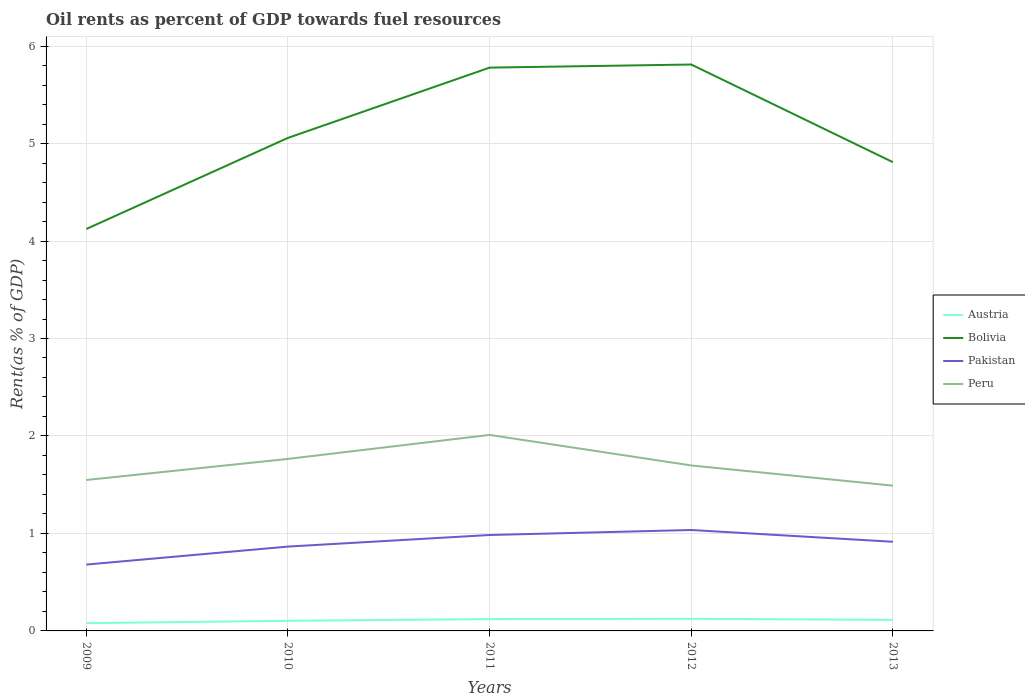Across all years, what is the maximum oil rent in Austria?
Provide a short and direct response. 0.08. In which year was the oil rent in Pakistan maximum?
Ensure brevity in your answer.  2009. What is the total oil rent in Bolivia in the graph?
Your response must be concise. -0.93. What is the difference between the highest and the second highest oil rent in Bolivia?
Provide a short and direct response. 1.69. What is the difference between the highest and the lowest oil rent in Peru?
Provide a succinct answer. 2. How many years are there in the graph?
Your answer should be compact. 5. What is the difference between two consecutive major ticks on the Y-axis?
Offer a terse response. 1. Are the values on the major ticks of Y-axis written in scientific E-notation?
Offer a terse response. No. Does the graph contain any zero values?
Keep it short and to the point. No. Does the graph contain grids?
Provide a succinct answer. Yes. Where does the legend appear in the graph?
Your response must be concise. Center right. How many legend labels are there?
Keep it short and to the point. 4. How are the legend labels stacked?
Make the answer very short. Vertical. What is the title of the graph?
Offer a very short reply. Oil rents as percent of GDP towards fuel resources. What is the label or title of the Y-axis?
Make the answer very short. Rent(as % of GDP). What is the Rent(as % of GDP) in Austria in 2009?
Offer a terse response. 0.08. What is the Rent(as % of GDP) in Bolivia in 2009?
Ensure brevity in your answer.  4.12. What is the Rent(as % of GDP) in Pakistan in 2009?
Offer a terse response. 0.68. What is the Rent(as % of GDP) in Peru in 2009?
Give a very brief answer. 1.55. What is the Rent(as % of GDP) of Austria in 2010?
Provide a succinct answer. 0.1. What is the Rent(as % of GDP) in Bolivia in 2010?
Keep it short and to the point. 5.06. What is the Rent(as % of GDP) of Pakistan in 2010?
Give a very brief answer. 0.87. What is the Rent(as % of GDP) of Peru in 2010?
Offer a terse response. 1.76. What is the Rent(as % of GDP) of Austria in 2011?
Provide a succinct answer. 0.12. What is the Rent(as % of GDP) of Bolivia in 2011?
Provide a succinct answer. 5.78. What is the Rent(as % of GDP) of Pakistan in 2011?
Provide a short and direct response. 0.98. What is the Rent(as % of GDP) of Peru in 2011?
Your answer should be very brief. 2.01. What is the Rent(as % of GDP) of Austria in 2012?
Your answer should be compact. 0.12. What is the Rent(as % of GDP) in Bolivia in 2012?
Offer a terse response. 5.81. What is the Rent(as % of GDP) of Pakistan in 2012?
Keep it short and to the point. 1.04. What is the Rent(as % of GDP) of Peru in 2012?
Ensure brevity in your answer.  1.7. What is the Rent(as % of GDP) in Austria in 2013?
Offer a very short reply. 0.11. What is the Rent(as % of GDP) of Bolivia in 2013?
Your response must be concise. 4.81. What is the Rent(as % of GDP) of Pakistan in 2013?
Keep it short and to the point. 0.91. What is the Rent(as % of GDP) in Peru in 2013?
Offer a terse response. 1.49. Across all years, what is the maximum Rent(as % of GDP) of Austria?
Give a very brief answer. 0.12. Across all years, what is the maximum Rent(as % of GDP) of Bolivia?
Offer a very short reply. 5.81. Across all years, what is the maximum Rent(as % of GDP) of Pakistan?
Keep it short and to the point. 1.04. Across all years, what is the maximum Rent(as % of GDP) of Peru?
Provide a short and direct response. 2.01. Across all years, what is the minimum Rent(as % of GDP) in Austria?
Your response must be concise. 0.08. Across all years, what is the minimum Rent(as % of GDP) in Bolivia?
Your answer should be compact. 4.12. Across all years, what is the minimum Rent(as % of GDP) in Pakistan?
Offer a terse response. 0.68. Across all years, what is the minimum Rent(as % of GDP) in Peru?
Make the answer very short. 1.49. What is the total Rent(as % of GDP) in Austria in the graph?
Offer a very short reply. 0.54. What is the total Rent(as % of GDP) of Bolivia in the graph?
Make the answer very short. 25.58. What is the total Rent(as % of GDP) in Pakistan in the graph?
Make the answer very short. 4.48. What is the total Rent(as % of GDP) of Peru in the graph?
Provide a short and direct response. 8.51. What is the difference between the Rent(as % of GDP) in Austria in 2009 and that in 2010?
Your answer should be very brief. -0.02. What is the difference between the Rent(as % of GDP) in Bolivia in 2009 and that in 2010?
Make the answer very short. -0.93. What is the difference between the Rent(as % of GDP) in Pakistan in 2009 and that in 2010?
Keep it short and to the point. -0.18. What is the difference between the Rent(as % of GDP) in Peru in 2009 and that in 2010?
Offer a terse response. -0.22. What is the difference between the Rent(as % of GDP) of Austria in 2009 and that in 2011?
Keep it short and to the point. -0.04. What is the difference between the Rent(as % of GDP) in Bolivia in 2009 and that in 2011?
Provide a succinct answer. -1.66. What is the difference between the Rent(as % of GDP) in Pakistan in 2009 and that in 2011?
Keep it short and to the point. -0.3. What is the difference between the Rent(as % of GDP) of Peru in 2009 and that in 2011?
Offer a very short reply. -0.46. What is the difference between the Rent(as % of GDP) of Austria in 2009 and that in 2012?
Give a very brief answer. -0.04. What is the difference between the Rent(as % of GDP) of Bolivia in 2009 and that in 2012?
Offer a very short reply. -1.69. What is the difference between the Rent(as % of GDP) in Pakistan in 2009 and that in 2012?
Ensure brevity in your answer.  -0.35. What is the difference between the Rent(as % of GDP) of Peru in 2009 and that in 2012?
Your answer should be very brief. -0.15. What is the difference between the Rent(as % of GDP) in Austria in 2009 and that in 2013?
Your response must be concise. -0.03. What is the difference between the Rent(as % of GDP) in Bolivia in 2009 and that in 2013?
Your answer should be very brief. -0.69. What is the difference between the Rent(as % of GDP) in Pakistan in 2009 and that in 2013?
Your response must be concise. -0.23. What is the difference between the Rent(as % of GDP) in Peru in 2009 and that in 2013?
Your answer should be compact. 0.06. What is the difference between the Rent(as % of GDP) of Austria in 2010 and that in 2011?
Your answer should be compact. -0.02. What is the difference between the Rent(as % of GDP) of Bolivia in 2010 and that in 2011?
Keep it short and to the point. -0.72. What is the difference between the Rent(as % of GDP) in Pakistan in 2010 and that in 2011?
Give a very brief answer. -0.12. What is the difference between the Rent(as % of GDP) of Peru in 2010 and that in 2011?
Make the answer very short. -0.25. What is the difference between the Rent(as % of GDP) in Austria in 2010 and that in 2012?
Keep it short and to the point. -0.02. What is the difference between the Rent(as % of GDP) in Bolivia in 2010 and that in 2012?
Provide a short and direct response. -0.75. What is the difference between the Rent(as % of GDP) of Pakistan in 2010 and that in 2012?
Your response must be concise. -0.17. What is the difference between the Rent(as % of GDP) of Peru in 2010 and that in 2012?
Provide a succinct answer. 0.07. What is the difference between the Rent(as % of GDP) of Austria in 2010 and that in 2013?
Provide a succinct answer. -0.01. What is the difference between the Rent(as % of GDP) in Bolivia in 2010 and that in 2013?
Offer a very short reply. 0.25. What is the difference between the Rent(as % of GDP) in Pakistan in 2010 and that in 2013?
Your answer should be very brief. -0.05. What is the difference between the Rent(as % of GDP) in Peru in 2010 and that in 2013?
Make the answer very short. 0.27. What is the difference between the Rent(as % of GDP) of Austria in 2011 and that in 2012?
Make the answer very short. -0. What is the difference between the Rent(as % of GDP) of Bolivia in 2011 and that in 2012?
Keep it short and to the point. -0.03. What is the difference between the Rent(as % of GDP) of Pakistan in 2011 and that in 2012?
Ensure brevity in your answer.  -0.05. What is the difference between the Rent(as % of GDP) of Peru in 2011 and that in 2012?
Keep it short and to the point. 0.31. What is the difference between the Rent(as % of GDP) in Austria in 2011 and that in 2013?
Offer a terse response. 0.01. What is the difference between the Rent(as % of GDP) of Bolivia in 2011 and that in 2013?
Offer a terse response. 0.97. What is the difference between the Rent(as % of GDP) in Pakistan in 2011 and that in 2013?
Your answer should be very brief. 0.07. What is the difference between the Rent(as % of GDP) of Peru in 2011 and that in 2013?
Keep it short and to the point. 0.52. What is the difference between the Rent(as % of GDP) in Austria in 2012 and that in 2013?
Ensure brevity in your answer.  0.01. What is the difference between the Rent(as % of GDP) of Pakistan in 2012 and that in 2013?
Your response must be concise. 0.12. What is the difference between the Rent(as % of GDP) of Peru in 2012 and that in 2013?
Provide a succinct answer. 0.21. What is the difference between the Rent(as % of GDP) in Austria in 2009 and the Rent(as % of GDP) in Bolivia in 2010?
Your answer should be compact. -4.98. What is the difference between the Rent(as % of GDP) in Austria in 2009 and the Rent(as % of GDP) in Pakistan in 2010?
Your response must be concise. -0.79. What is the difference between the Rent(as % of GDP) of Austria in 2009 and the Rent(as % of GDP) of Peru in 2010?
Provide a short and direct response. -1.69. What is the difference between the Rent(as % of GDP) in Bolivia in 2009 and the Rent(as % of GDP) in Pakistan in 2010?
Offer a very short reply. 3.26. What is the difference between the Rent(as % of GDP) of Bolivia in 2009 and the Rent(as % of GDP) of Peru in 2010?
Your response must be concise. 2.36. What is the difference between the Rent(as % of GDP) of Pakistan in 2009 and the Rent(as % of GDP) of Peru in 2010?
Offer a terse response. -1.08. What is the difference between the Rent(as % of GDP) of Austria in 2009 and the Rent(as % of GDP) of Bolivia in 2011?
Make the answer very short. -5.7. What is the difference between the Rent(as % of GDP) in Austria in 2009 and the Rent(as % of GDP) in Pakistan in 2011?
Provide a succinct answer. -0.9. What is the difference between the Rent(as % of GDP) in Austria in 2009 and the Rent(as % of GDP) in Peru in 2011?
Give a very brief answer. -1.93. What is the difference between the Rent(as % of GDP) in Bolivia in 2009 and the Rent(as % of GDP) in Pakistan in 2011?
Give a very brief answer. 3.14. What is the difference between the Rent(as % of GDP) of Bolivia in 2009 and the Rent(as % of GDP) of Peru in 2011?
Make the answer very short. 2.11. What is the difference between the Rent(as % of GDP) of Pakistan in 2009 and the Rent(as % of GDP) of Peru in 2011?
Provide a short and direct response. -1.33. What is the difference between the Rent(as % of GDP) in Austria in 2009 and the Rent(as % of GDP) in Bolivia in 2012?
Make the answer very short. -5.73. What is the difference between the Rent(as % of GDP) of Austria in 2009 and the Rent(as % of GDP) of Pakistan in 2012?
Offer a terse response. -0.96. What is the difference between the Rent(as % of GDP) in Austria in 2009 and the Rent(as % of GDP) in Peru in 2012?
Your response must be concise. -1.62. What is the difference between the Rent(as % of GDP) in Bolivia in 2009 and the Rent(as % of GDP) in Pakistan in 2012?
Offer a terse response. 3.09. What is the difference between the Rent(as % of GDP) of Bolivia in 2009 and the Rent(as % of GDP) of Peru in 2012?
Ensure brevity in your answer.  2.43. What is the difference between the Rent(as % of GDP) in Pakistan in 2009 and the Rent(as % of GDP) in Peru in 2012?
Offer a terse response. -1.02. What is the difference between the Rent(as % of GDP) in Austria in 2009 and the Rent(as % of GDP) in Bolivia in 2013?
Your response must be concise. -4.73. What is the difference between the Rent(as % of GDP) in Austria in 2009 and the Rent(as % of GDP) in Pakistan in 2013?
Your response must be concise. -0.84. What is the difference between the Rent(as % of GDP) of Austria in 2009 and the Rent(as % of GDP) of Peru in 2013?
Offer a very short reply. -1.41. What is the difference between the Rent(as % of GDP) in Bolivia in 2009 and the Rent(as % of GDP) in Pakistan in 2013?
Your response must be concise. 3.21. What is the difference between the Rent(as % of GDP) of Bolivia in 2009 and the Rent(as % of GDP) of Peru in 2013?
Make the answer very short. 2.63. What is the difference between the Rent(as % of GDP) in Pakistan in 2009 and the Rent(as % of GDP) in Peru in 2013?
Provide a succinct answer. -0.81. What is the difference between the Rent(as % of GDP) in Austria in 2010 and the Rent(as % of GDP) in Bolivia in 2011?
Keep it short and to the point. -5.67. What is the difference between the Rent(as % of GDP) in Austria in 2010 and the Rent(as % of GDP) in Pakistan in 2011?
Offer a terse response. -0.88. What is the difference between the Rent(as % of GDP) of Austria in 2010 and the Rent(as % of GDP) of Peru in 2011?
Your answer should be compact. -1.91. What is the difference between the Rent(as % of GDP) in Bolivia in 2010 and the Rent(as % of GDP) in Pakistan in 2011?
Ensure brevity in your answer.  4.07. What is the difference between the Rent(as % of GDP) in Bolivia in 2010 and the Rent(as % of GDP) in Peru in 2011?
Provide a succinct answer. 3.05. What is the difference between the Rent(as % of GDP) of Pakistan in 2010 and the Rent(as % of GDP) of Peru in 2011?
Provide a succinct answer. -1.15. What is the difference between the Rent(as % of GDP) in Austria in 2010 and the Rent(as % of GDP) in Bolivia in 2012?
Offer a terse response. -5.71. What is the difference between the Rent(as % of GDP) of Austria in 2010 and the Rent(as % of GDP) of Pakistan in 2012?
Keep it short and to the point. -0.93. What is the difference between the Rent(as % of GDP) of Austria in 2010 and the Rent(as % of GDP) of Peru in 2012?
Provide a short and direct response. -1.59. What is the difference between the Rent(as % of GDP) of Bolivia in 2010 and the Rent(as % of GDP) of Pakistan in 2012?
Offer a terse response. 4.02. What is the difference between the Rent(as % of GDP) in Bolivia in 2010 and the Rent(as % of GDP) in Peru in 2012?
Keep it short and to the point. 3.36. What is the difference between the Rent(as % of GDP) of Pakistan in 2010 and the Rent(as % of GDP) of Peru in 2012?
Offer a terse response. -0.83. What is the difference between the Rent(as % of GDP) of Austria in 2010 and the Rent(as % of GDP) of Bolivia in 2013?
Provide a succinct answer. -4.71. What is the difference between the Rent(as % of GDP) in Austria in 2010 and the Rent(as % of GDP) in Pakistan in 2013?
Offer a terse response. -0.81. What is the difference between the Rent(as % of GDP) of Austria in 2010 and the Rent(as % of GDP) of Peru in 2013?
Keep it short and to the point. -1.39. What is the difference between the Rent(as % of GDP) in Bolivia in 2010 and the Rent(as % of GDP) in Pakistan in 2013?
Keep it short and to the point. 4.14. What is the difference between the Rent(as % of GDP) in Bolivia in 2010 and the Rent(as % of GDP) in Peru in 2013?
Offer a terse response. 3.57. What is the difference between the Rent(as % of GDP) of Pakistan in 2010 and the Rent(as % of GDP) of Peru in 2013?
Provide a succinct answer. -0.63. What is the difference between the Rent(as % of GDP) of Austria in 2011 and the Rent(as % of GDP) of Bolivia in 2012?
Keep it short and to the point. -5.69. What is the difference between the Rent(as % of GDP) in Austria in 2011 and the Rent(as % of GDP) in Pakistan in 2012?
Make the answer very short. -0.91. What is the difference between the Rent(as % of GDP) of Austria in 2011 and the Rent(as % of GDP) of Peru in 2012?
Provide a short and direct response. -1.58. What is the difference between the Rent(as % of GDP) in Bolivia in 2011 and the Rent(as % of GDP) in Pakistan in 2012?
Your answer should be compact. 4.74. What is the difference between the Rent(as % of GDP) of Bolivia in 2011 and the Rent(as % of GDP) of Peru in 2012?
Your answer should be very brief. 4.08. What is the difference between the Rent(as % of GDP) of Pakistan in 2011 and the Rent(as % of GDP) of Peru in 2012?
Make the answer very short. -0.71. What is the difference between the Rent(as % of GDP) in Austria in 2011 and the Rent(as % of GDP) in Bolivia in 2013?
Provide a short and direct response. -4.69. What is the difference between the Rent(as % of GDP) of Austria in 2011 and the Rent(as % of GDP) of Pakistan in 2013?
Provide a short and direct response. -0.79. What is the difference between the Rent(as % of GDP) of Austria in 2011 and the Rent(as % of GDP) of Peru in 2013?
Your answer should be compact. -1.37. What is the difference between the Rent(as % of GDP) of Bolivia in 2011 and the Rent(as % of GDP) of Pakistan in 2013?
Make the answer very short. 4.86. What is the difference between the Rent(as % of GDP) in Bolivia in 2011 and the Rent(as % of GDP) in Peru in 2013?
Your answer should be very brief. 4.29. What is the difference between the Rent(as % of GDP) in Pakistan in 2011 and the Rent(as % of GDP) in Peru in 2013?
Keep it short and to the point. -0.51. What is the difference between the Rent(as % of GDP) of Austria in 2012 and the Rent(as % of GDP) of Bolivia in 2013?
Offer a very short reply. -4.69. What is the difference between the Rent(as % of GDP) in Austria in 2012 and the Rent(as % of GDP) in Pakistan in 2013?
Make the answer very short. -0.79. What is the difference between the Rent(as % of GDP) of Austria in 2012 and the Rent(as % of GDP) of Peru in 2013?
Offer a terse response. -1.37. What is the difference between the Rent(as % of GDP) in Bolivia in 2012 and the Rent(as % of GDP) in Pakistan in 2013?
Offer a very short reply. 4.9. What is the difference between the Rent(as % of GDP) in Bolivia in 2012 and the Rent(as % of GDP) in Peru in 2013?
Your response must be concise. 4.32. What is the difference between the Rent(as % of GDP) in Pakistan in 2012 and the Rent(as % of GDP) in Peru in 2013?
Make the answer very short. -0.46. What is the average Rent(as % of GDP) of Austria per year?
Give a very brief answer. 0.11. What is the average Rent(as % of GDP) in Bolivia per year?
Give a very brief answer. 5.12. What is the average Rent(as % of GDP) in Pakistan per year?
Provide a succinct answer. 0.9. What is the average Rent(as % of GDP) in Peru per year?
Your answer should be very brief. 1.7. In the year 2009, what is the difference between the Rent(as % of GDP) of Austria and Rent(as % of GDP) of Bolivia?
Offer a terse response. -4.04. In the year 2009, what is the difference between the Rent(as % of GDP) of Austria and Rent(as % of GDP) of Pakistan?
Provide a succinct answer. -0.6. In the year 2009, what is the difference between the Rent(as % of GDP) in Austria and Rent(as % of GDP) in Peru?
Offer a very short reply. -1.47. In the year 2009, what is the difference between the Rent(as % of GDP) in Bolivia and Rent(as % of GDP) in Pakistan?
Provide a short and direct response. 3.44. In the year 2009, what is the difference between the Rent(as % of GDP) of Bolivia and Rent(as % of GDP) of Peru?
Your answer should be compact. 2.58. In the year 2009, what is the difference between the Rent(as % of GDP) of Pakistan and Rent(as % of GDP) of Peru?
Make the answer very short. -0.87. In the year 2010, what is the difference between the Rent(as % of GDP) of Austria and Rent(as % of GDP) of Bolivia?
Ensure brevity in your answer.  -4.95. In the year 2010, what is the difference between the Rent(as % of GDP) of Austria and Rent(as % of GDP) of Pakistan?
Give a very brief answer. -0.76. In the year 2010, what is the difference between the Rent(as % of GDP) of Austria and Rent(as % of GDP) of Peru?
Keep it short and to the point. -1.66. In the year 2010, what is the difference between the Rent(as % of GDP) of Bolivia and Rent(as % of GDP) of Pakistan?
Provide a succinct answer. 4.19. In the year 2010, what is the difference between the Rent(as % of GDP) of Bolivia and Rent(as % of GDP) of Peru?
Your answer should be very brief. 3.29. In the year 2010, what is the difference between the Rent(as % of GDP) of Pakistan and Rent(as % of GDP) of Peru?
Provide a succinct answer. -0.9. In the year 2011, what is the difference between the Rent(as % of GDP) of Austria and Rent(as % of GDP) of Bolivia?
Offer a very short reply. -5.66. In the year 2011, what is the difference between the Rent(as % of GDP) of Austria and Rent(as % of GDP) of Pakistan?
Give a very brief answer. -0.86. In the year 2011, what is the difference between the Rent(as % of GDP) in Austria and Rent(as % of GDP) in Peru?
Make the answer very short. -1.89. In the year 2011, what is the difference between the Rent(as % of GDP) in Bolivia and Rent(as % of GDP) in Pakistan?
Your response must be concise. 4.79. In the year 2011, what is the difference between the Rent(as % of GDP) in Bolivia and Rent(as % of GDP) in Peru?
Your answer should be compact. 3.77. In the year 2011, what is the difference between the Rent(as % of GDP) in Pakistan and Rent(as % of GDP) in Peru?
Your answer should be very brief. -1.03. In the year 2012, what is the difference between the Rent(as % of GDP) of Austria and Rent(as % of GDP) of Bolivia?
Make the answer very short. -5.69. In the year 2012, what is the difference between the Rent(as % of GDP) of Austria and Rent(as % of GDP) of Pakistan?
Provide a short and direct response. -0.91. In the year 2012, what is the difference between the Rent(as % of GDP) in Austria and Rent(as % of GDP) in Peru?
Keep it short and to the point. -1.57. In the year 2012, what is the difference between the Rent(as % of GDP) of Bolivia and Rent(as % of GDP) of Pakistan?
Ensure brevity in your answer.  4.78. In the year 2012, what is the difference between the Rent(as % of GDP) of Bolivia and Rent(as % of GDP) of Peru?
Offer a very short reply. 4.11. In the year 2012, what is the difference between the Rent(as % of GDP) in Pakistan and Rent(as % of GDP) in Peru?
Your answer should be very brief. -0.66. In the year 2013, what is the difference between the Rent(as % of GDP) in Austria and Rent(as % of GDP) in Bolivia?
Provide a succinct answer. -4.7. In the year 2013, what is the difference between the Rent(as % of GDP) of Austria and Rent(as % of GDP) of Pakistan?
Offer a very short reply. -0.8. In the year 2013, what is the difference between the Rent(as % of GDP) in Austria and Rent(as % of GDP) in Peru?
Keep it short and to the point. -1.38. In the year 2013, what is the difference between the Rent(as % of GDP) in Bolivia and Rent(as % of GDP) in Pakistan?
Make the answer very short. 3.89. In the year 2013, what is the difference between the Rent(as % of GDP) in Bolivia and Rent(as % of GDP) in Peru?
Keep it short and to the point. 3.32. In the year 2013, what is the difference between the Rent(as % of GDP) in Pakistan and Rent(as % of GDP) in Peru?
Provide a succinct answer. -0.58. What is the ratio of the Rent(as % of GDP) of Austria in 2009 to that in 2010?
Give a very brief answer. 0.77. What is the ratio of the Rent(as % of GDP) in Bolivia in 2009 to that in 2010?
Keep it short and to the point. 0.82. What is the ratio of the Rent(as % of GDP) in Pakistan in 2009 to that in 2010?
Provide a short and direct response. 0.79. What is the ratio of the Rent(as % of GDP) in Peru in 2009 to that in 2010?
Offer a terse response. 0.88. What is the ratio of the Rent(as % of GDP) of Austria in 2009 to that in 2011?
Offer a very short reply. 0.66. What is the ratio of the Rent(as % of GDP) in Bolivia in 2009 to that in 2011?
Offer a very short reply. 0.71. What is the ratio of the Rent(as % of GDP) of Pakistan in 2009 to that in 2011?
Your answer should be compact. 0.69. What is the ratio of the Rent(as % of GDP) of Peru in 2009 to that in 2011?
Make the answer very short. 0.77. What is the ratio of the Rent(as % of GDP) of Austria in 2009 to that in 2012?
Offer a terse response. 0.64. What is the ratio of the Rent(as % of GDP) in Bolivia in 2009 to that in 2012?
Keep it short and to the point. 0.71. What is the ratio of the Rent(as % of GDP) of Pakistan in 2009 to that in 2012?
Your answer should be very brief. 0.66. What is the ratio of the Rent(as % of GDP) in Peru in 2009 to that in 2012?
Give a very brief answer. 0.91. What is the ratio of the Rent(as % of GDP) of Austria in 2009 to that in 2013?
Your response must be concise. 0.7. What is the ratio of the Rent(as % of GDP) in Bolivia in 2009 to that in 2013?
Your answer should be very brief. 0.86. What is the ratio of the Rent(as % of GDP) of Pakistan in 2009 to that in 2013?
Provide a short and direct response. 0.74. What is the ratio of the Rent(as % of GDP) in Peru in 2009 to that in 2013?
Your answer should be very brief. 1.04. What is the ratio of the Rent(as % of GDP) in Austria in 2010 to that in 2011?
Ensure brevity in your answer.  0.86. What is the ratio of the Rent(as % of GDP) in Bolivia in 2010 to that in 2011?
Make the answer very short. 0.88. What is the ratio of the Rent(as % of GDP) of Pakistan in 2010 to that in 2011?
Your answer should be compact. 0.88. What is the ratio of the Rent(as % of GDP) of Peru in 2010 to that in 2011?
Provide a short and direct response. 0.88. What is the ratio of the Rent(as % of GDP) in Austria in 2010 to that in 2012?
Make the answer very short. 0.84. What is the ratio of the Rent(as % of GDP) in Bolivia in 2010 to that in 2012?
Provide a succinct answer. 0.87. What is the ratio of the Rent(as % of GDP) in Pakistan in 2010 to that in 2012?
Provide a succinct answer. 0.84. What is the ratio of the Rent(as % of GDP) in Peru in 2010 to that in 2012?
Make the answer very short. 1.04. What is the ratio of the Rent(as % of GDP) of Austria in 2010 to that in 2013?
Provide a short and direct response. 0.92. What is the ratio of the Rent(as % of GDP) in Bolivia in 2010 to that in 2013?
Your response must be concise. 1.05. What is the ratio of the Rent(as % of GDP) of Pakistan in 2010 to that in 2013?
Provide a succinct answer. 0.95. What is the ratio of the Rent(as % of GDP) in Peru in 2010 to that in 2013?
Your response must be concise. 1.18. What is the ratio of the Rent(as % of GDP) of Austria in 2011 to that in 2012?
Make the answer very short. 0.98. What is the ratio of the Rent(as % of GDP) in Bolivia in 2011 to that in 2012?
Make the answer very short. 0.99. What is the ratio of the Rent(as % of GDP) of Pakistan in 2011 to that in 2012?
Give a very brief answer. 0.95. What is the ratio of the Rent(as % of GDP) of Peru in 2011 to that in 2012?
Give a very brief answer. 1.18. What is the ratio of the Rent(as % of GDP) in Austria in 2011 to that in 2013?
Ensure brevity in your answer.  1.07. What is the ratio of the Rent(as % of GDP) in Bolivia in 2011 to that in 2013?
Keep it short and to the point. 1.2. What is the ratio of the Rent(as % of GDP) of Pakistan in 2011 to that in 2013?
Your answer should be compact. 1.08. What is the ratio of the Rent(as % of GDP) in Peru in 2011 to that in 2013?
Your answer should be compact. 1.35. What is the ratio of the Rent(as % of GDP) in Austria in 2012 to that in 2013?
Your answer should be very brief. 1.1. What is the ratio of the Rent(as % of GDP) in Bolivia in 2012 to that in 2013?
Give a very brief answer. 1.21. What is the ratio of the Rent(as % of GDP) of Pakistan in 2012 to that in 2013?
Your response must be concise. 1.13. What is the ratio of the Rent(as % of GDP) of Peru in 2012 to that in 2013?
Offer a very short reply. 1.14. What is the difference between the highest and the second highest Rent(as % of GDP) in Austria?
Keep it short and to the point. 0. What is the difference between the highest and the second highest Rent(as % of GDP) of Bolivia?
Ensure brevity in your answer.  0.03. What is the difference between the highest and the second highest Rent(as % of GDP) of Pakistan?
Your response must be concise. 0.05. What is the difference between the highest and the second highest Rent(as % of GDP) of Peru?
Offer a very short reply. 0.25. What is the difference between the highest and the lowest Rent(as % of GDP) of Austria?
Provide a short and direct response. 0.04. What is the difference between the highest and the lowest Rent(as % of GDP) of Bolivia?
Your response must be concise. 1.69. What is the difference between the highest and the lowest Rent(as % of GDP) in Pakistan?
Offer a terse response. 0.35. What is the difference between the highest and the lowest Rent(as % of GDP) of Peru?
Your answer should be compact. 0.52. 